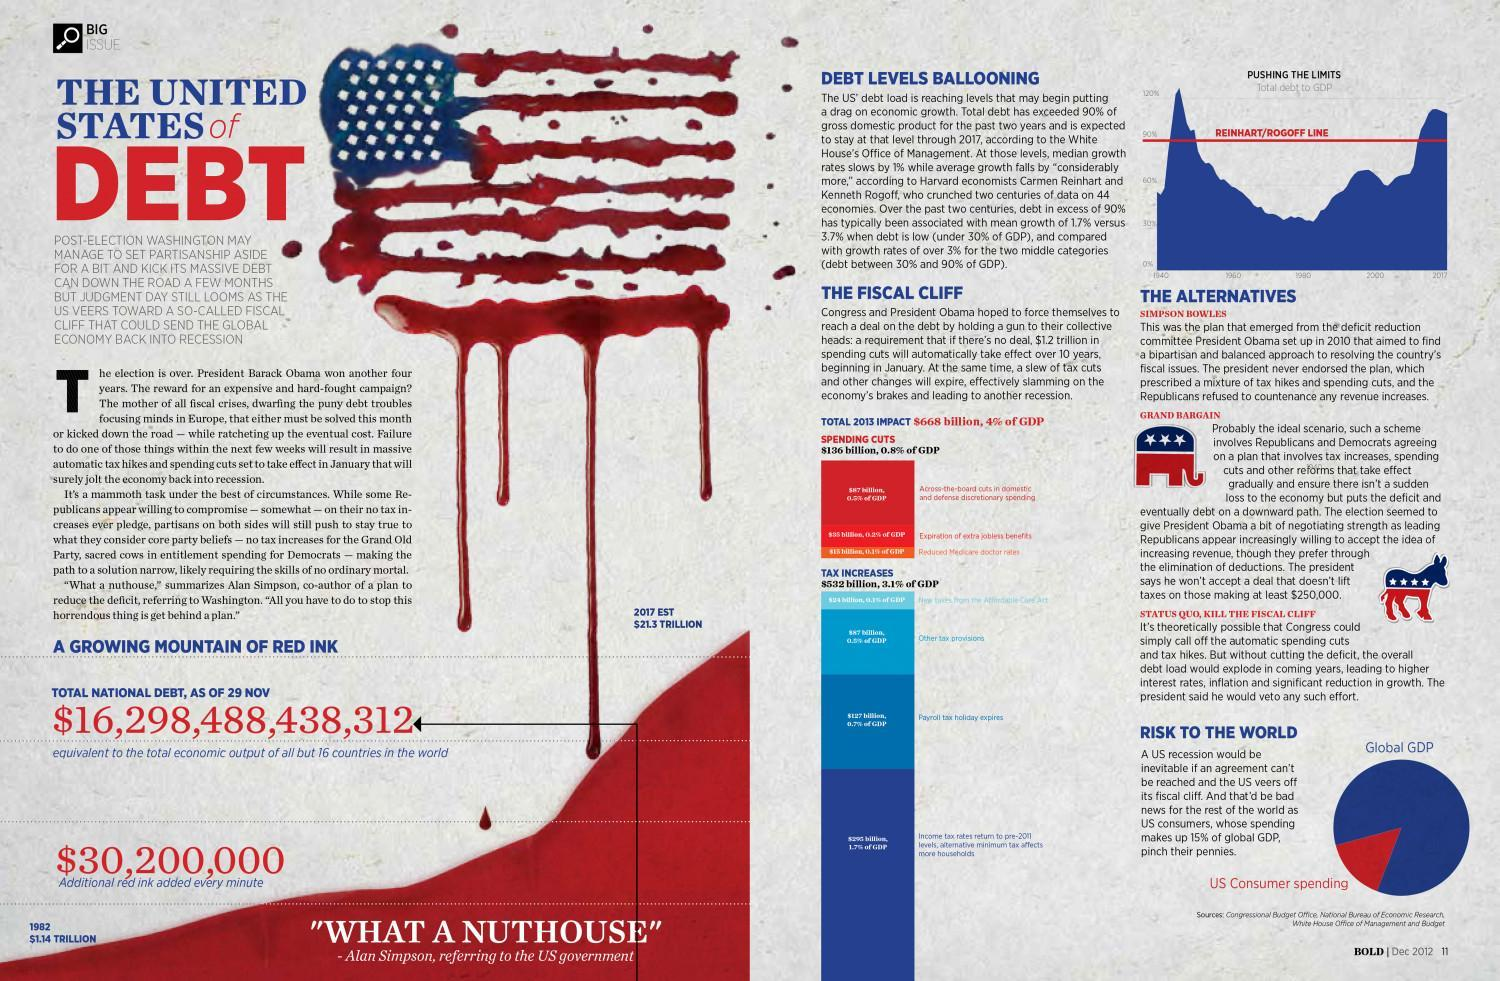What color is Global GDP in the pie chart, Blue or red?
Answer the question with a short phrase. blue How much spending cut will automatically take effect in 10 years if there's no deal? $1.2 trillion 